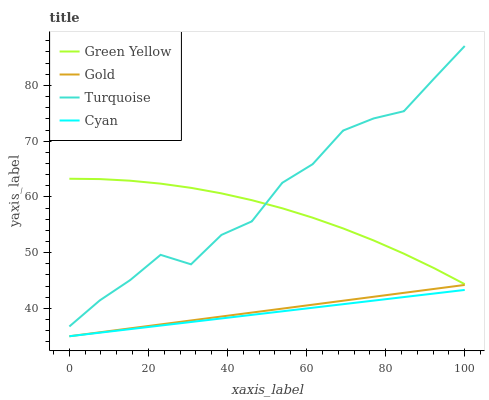Does Cyan have the minimum area under the curve?
Answer yes or no. Yes. Does Turquoise have the maximum area under the curve?
Answer yes or no. Yes. Does Green Yellow have the minimum area under the curve?
Answer yes or no. No. Does Green Yellow have the maximum area under the curve?
Answer yes or no. No. Is Cyan the smoothest?
Answer yes or no. Yes. Is Turquoise the roughest?
Answer yes or no. Yes. Is Green Yellow the smoothest?
Answer yes or no. No. Is Green Yellow the roughest?
Answer yes or no. No. Does Cyan have the lowest value?
Answer yes or no. Yes. Does Turquoise have the lowest value?
Answer yes or no. No. Does Turquoise have the highest value?
Answer yes or no. Yes. Does Green Yellow have the highest value?
Answer yes or no. No. Is Cyan less than Green Yellow?
Answer yes or no. Yes. Is Turquoise greater than Cyan?
Answer yes or no. Yes. Does Cyan intersect Gold?
Answer yes or no. Yes. Is Cyan less than Gold?
Answer yes or no. No. Is Cyan greater than Gold?
Answer yes or no. No. Does Cyan intersect Green Yellow?
Answer yes or no. No. 